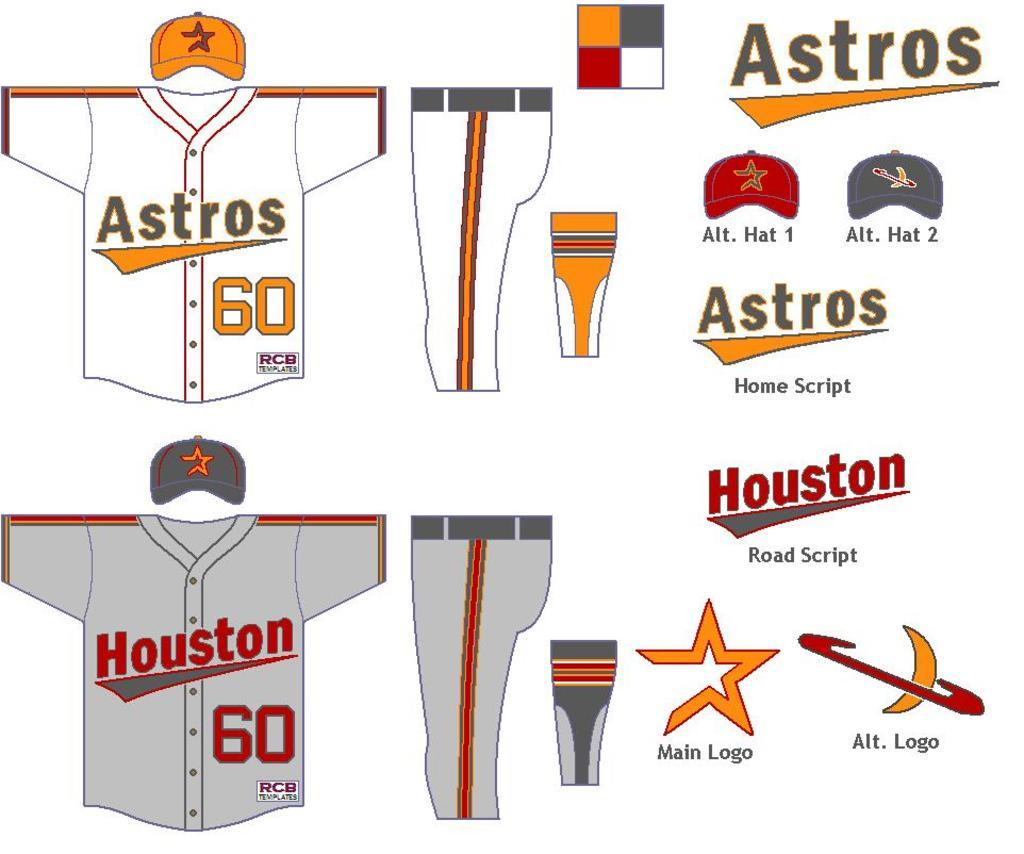<image>
Render a clear and concise summary of the photo. drawings for houston astros uniforms, hats, and logos 